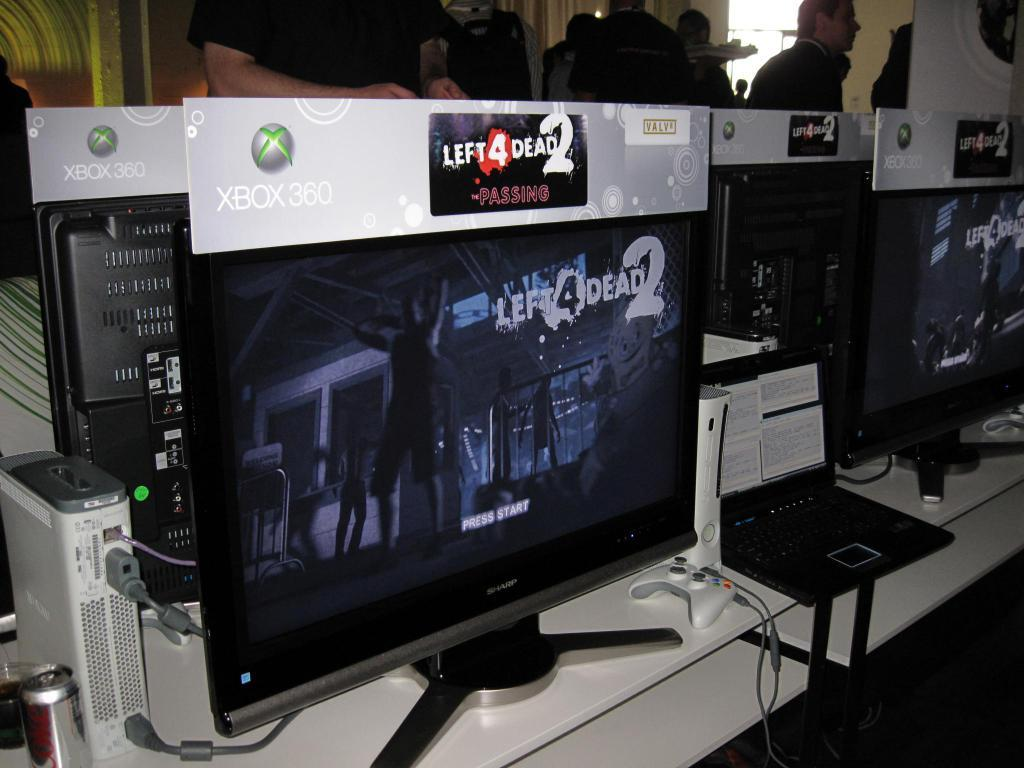Provide a one-sentence caption for the provided image. A computer monitor with XBox 360 Left 4 Dead 2 on the screen. 